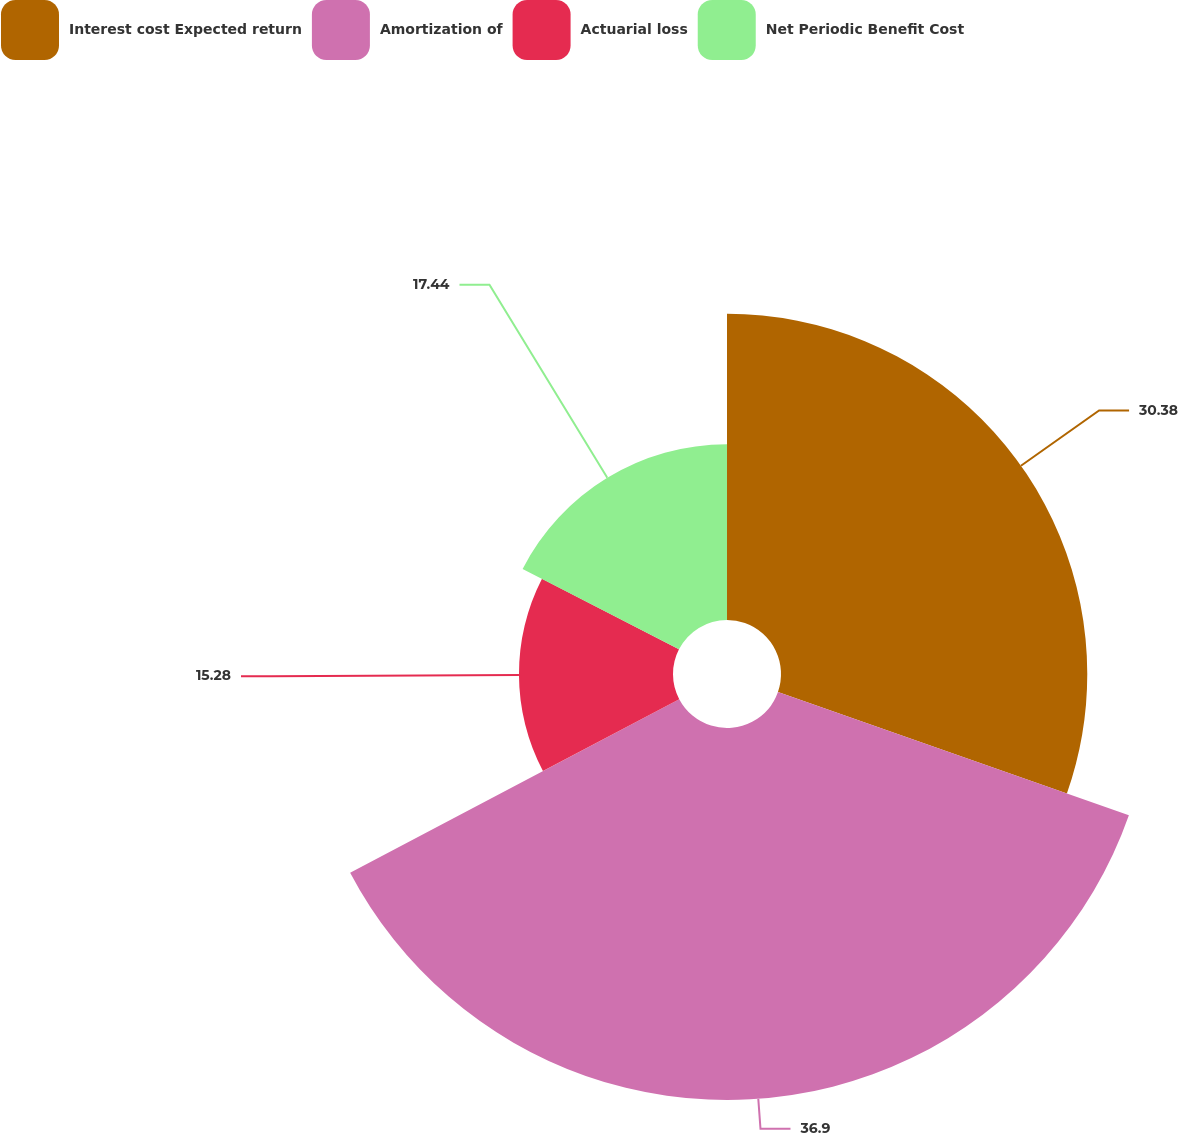<chart> <loc_0><loc_0><loc_500><loc_500><pie_chart><fcel>Interest cost Expected return<fcel>Amortization of<fcel>Actuarial loss<fcel>Net Periodic Benefit Cost<nl><fcel>30.38%<fcel>36.9%<fcel>15.28%<fcel>17.44%<nl></chart> 